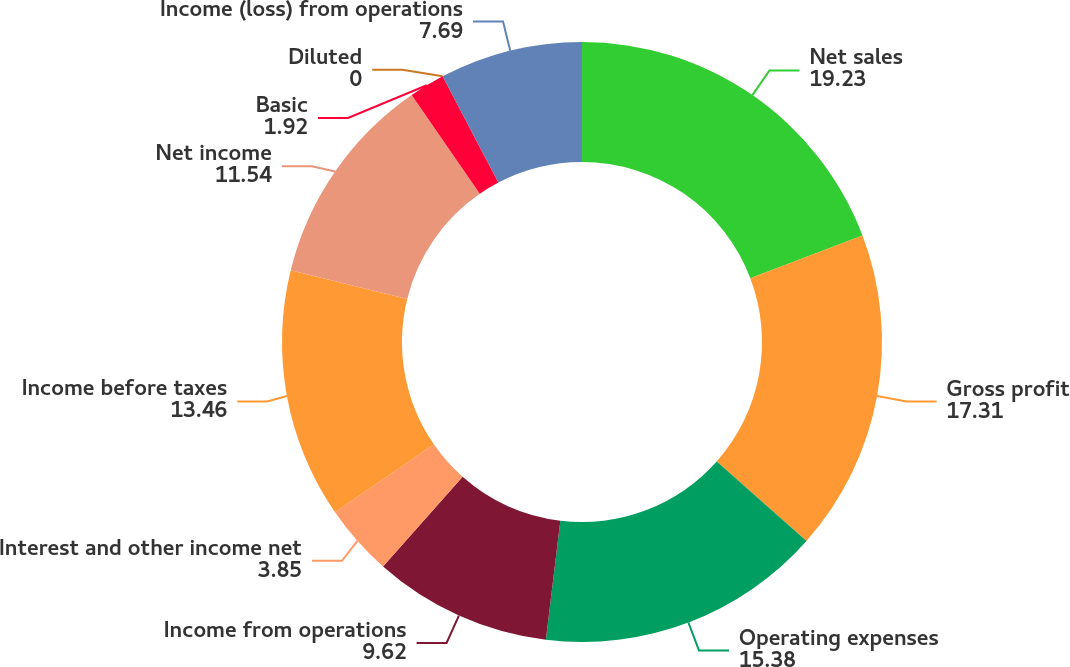Convert chart. <chart><loc_0><loc_0><loc_500><loc_500><pie_chart><fcel>Net sales<fcel>Gross profit<fcel>Operating expenses<fcel>Income from operations<fcel>Interest and other income net<fcel>Income before taxes<fcel>Net income<fcel>Basic<fcel>Diluted<fcel>Income (loss) from operations<nl><fcel>19.23%<fcel>17.31%<fcel>15.38%<fcel>9.62%<fcel>3.85%<fcel>13.46%<fcel>11.54%<fcel>1.92%<fcel>0.0%<fcel>7.69%<nl></chart> 